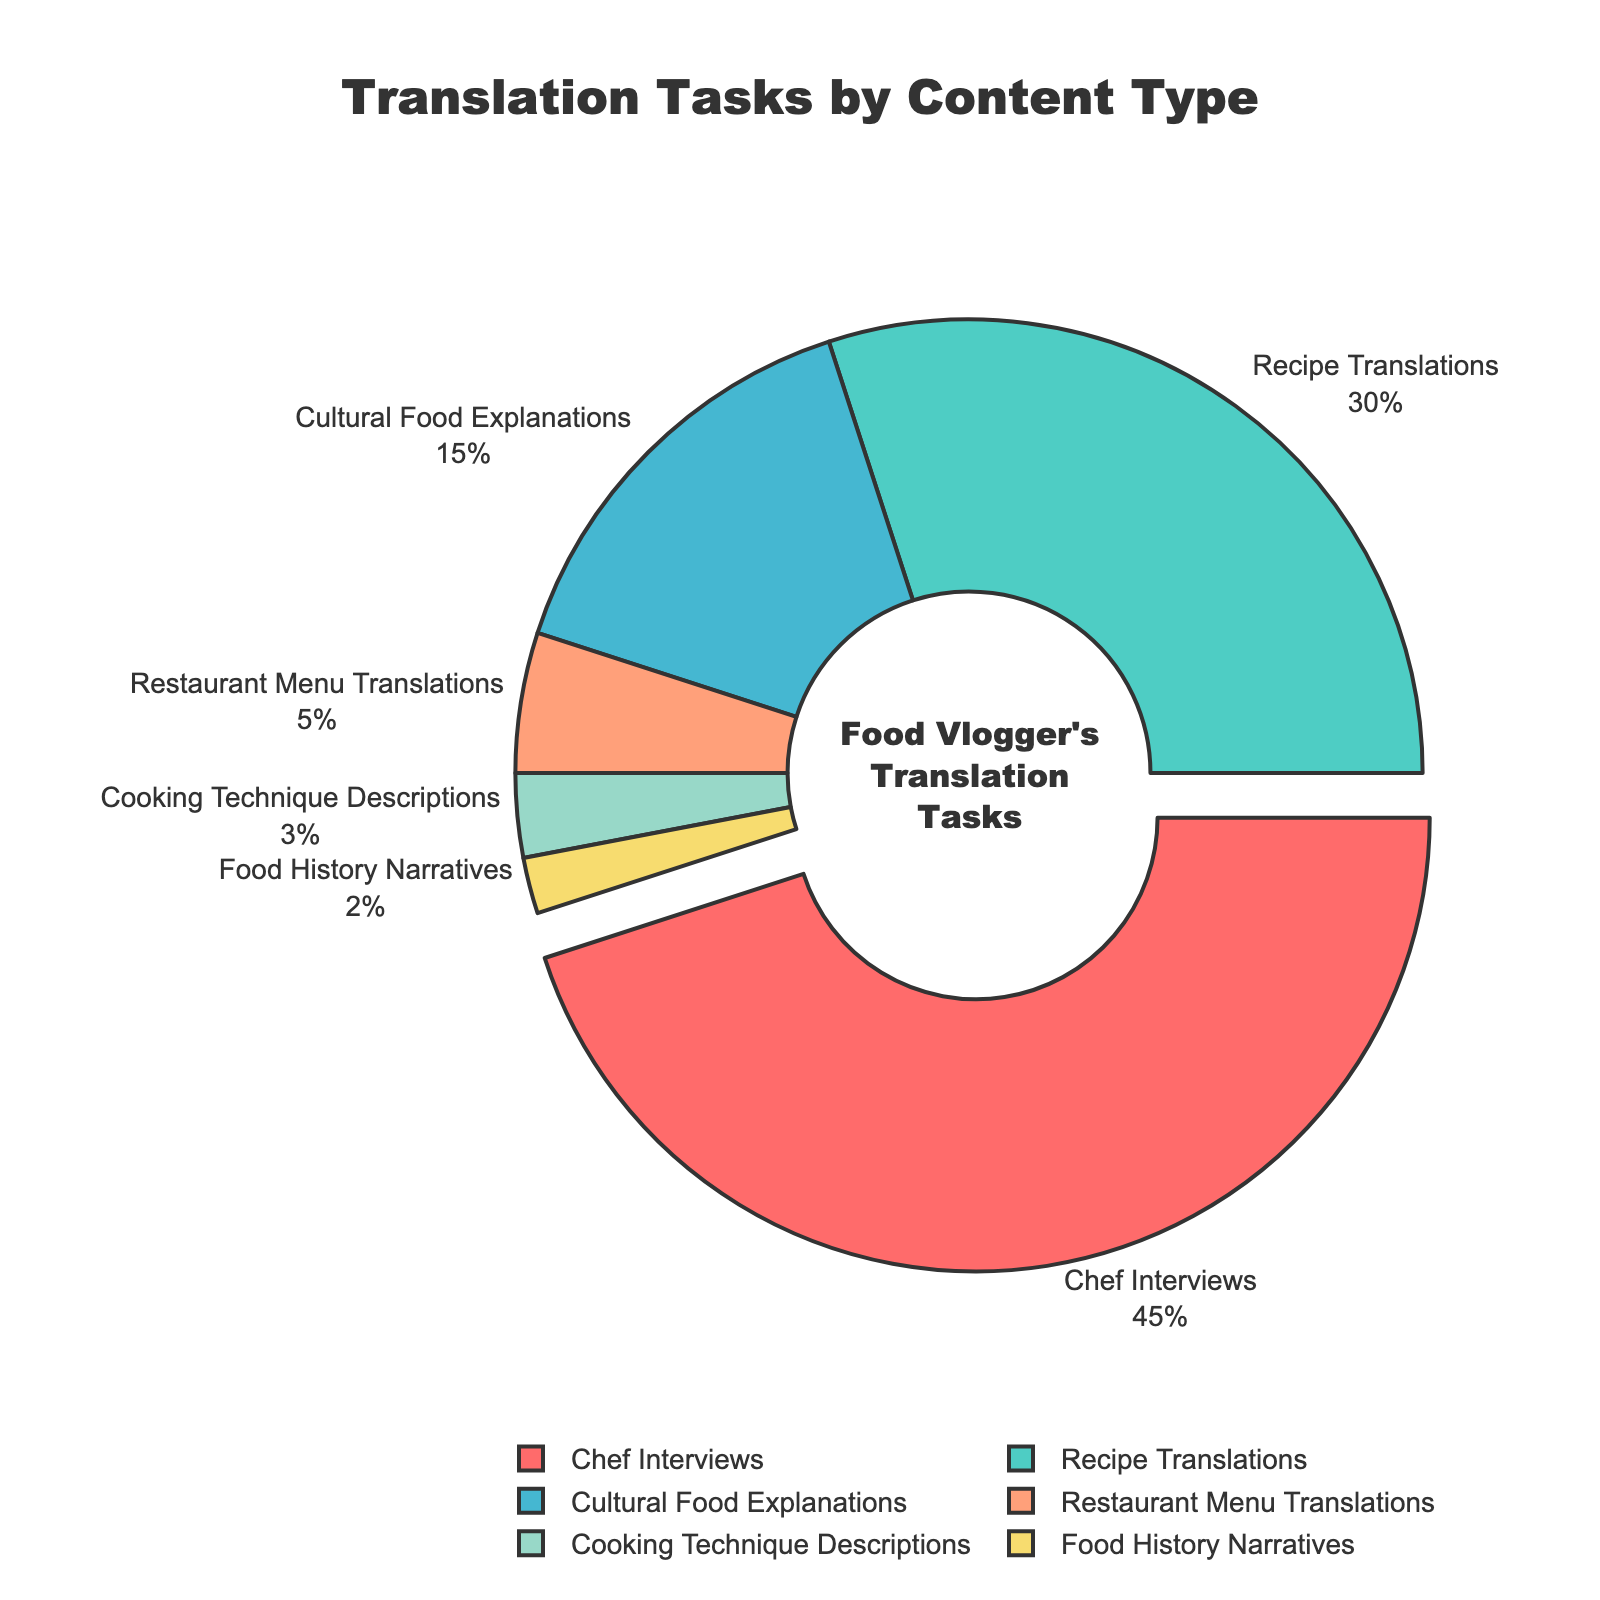What percentage of translation tasks are Chef Interviews? The pie chart shows that Chef Interviews take up 45% of the translation tasks.
Answer: 45% What content type has the smallest proportion of translation tasks? The smallest segment in the pie chart is labeled as Food History Narratives, which occupies 2%.
Answer: Food History Narratives How much greater is the proportion of Recipe Translations compared to Food History Narratives? Recipe Translations occupy 30% and Food History Narratives occupy 2%. The difference is 30% - 2% = 28%.
Answer: 28% Which content type is represented by the light blue color, and what is its proportion? The legend or pie chart shows that the light blue segment represents Recipe Translations, which is 30%.
Answer: Recipe Translations, 30% How much more do Chef Interviews and Recipe Translations together represent compared to Cultural Food Explanations? Chef Interviews and Recipe Translations together account for 45% + 30% = 75%. Cultural Food Explanations account for 15%. The difference is 75% - 15% = 60%.
Answer: 60% Arrange the content types in descending order of their proportion in the pie chart. From the largest to the smallest percentages: Chef Interviews (45%), Recipe Translations (30%), Cultural Food Explanations (15%), Restaurant Menu Translations (5%), Cooking Technique Descriptions (3%), Food History Narratives (2%).
Answer: Chef Interviews, Recipe Translations, Cultural Food Explanations, Restaurant Menu Translations, Cooking Technique Descriptions, Food History Narratives By how much does the proportion of Cooking Technique Descriptions exceed the proportion of Food History Narratives? Cooking Technique Descriptions represent 3%, and Food History Narratives represent 2%. The difference is 3% - 2% = 1%.
Answer: 1% What proportion of tasks is represented by Cultural Food Explanations and Restaurant Menu Translations combined? Cultural Food Explanations account for 15%, and Restaurant Menu Translations account for 5%. Combined, they are 15% + 5% = 20%.
Answer: 20% Identify the content types whose proportion adds up to 50% of the translation tasks. Recipe Translations (30%) and Cultural Food Explanations (15%) together make 45%. Adding the next smallest segment, Restaurant Menu Translations (5%), the total is 45% + 5% = 50%.
Answer: Recipe Translations, Cultural Food Explanations, Restaurant Menu Translations What is the total proportion of tasks that are not related to translating Chef Interviews or Recipe Translations? Chef Interviews and Recipe Translations together represent 45% + 30% = 75%. The remaining tasks represent 100% - 75% = 25%.
Answer: 25% 